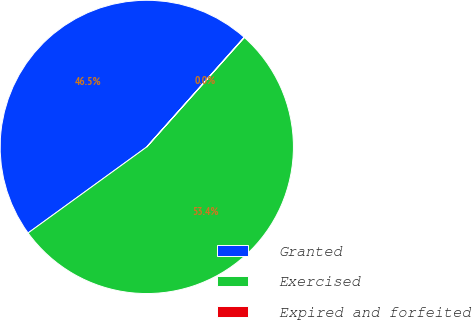Convert chart to OTSL. <chart><loc_0><loc_0><loc_500><loc_500><pie_chart><fcel>Granted<fcel>Exercised<fcel>Expired and forfeited<nl><fcel>46.54%<fcel>53.42%<fcel>0.03%<nl></chart> 